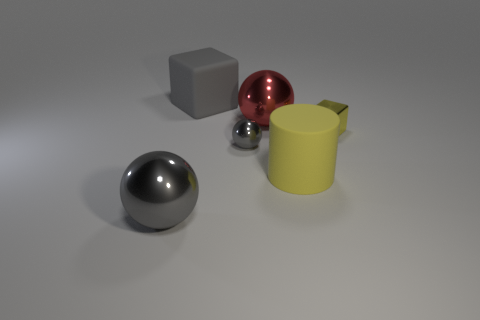Subtract all gray metal spheres. How many spheres are left? 1 Subtract all red spheres. How many spheres are left? 2 Add 2 tiny yellow blocks. How many objects exist? 8 Subtract all cylinders. How many objects are left? 5 Add 1 gray blocks. How many gray blocks are left? 2 Add 2 tiny green metal cubes. How many tiny green metal cubes exist? 2 Subtract 1 gray spheres. How many objects are left? 5 Subtract 1 cubes. How many cubes are left? 1 Subtract all purple cylinders. Subtract all gray balls. How many cylinders are left? 1 Subtract all cyan cylinders. How many green spheres are left? 0 